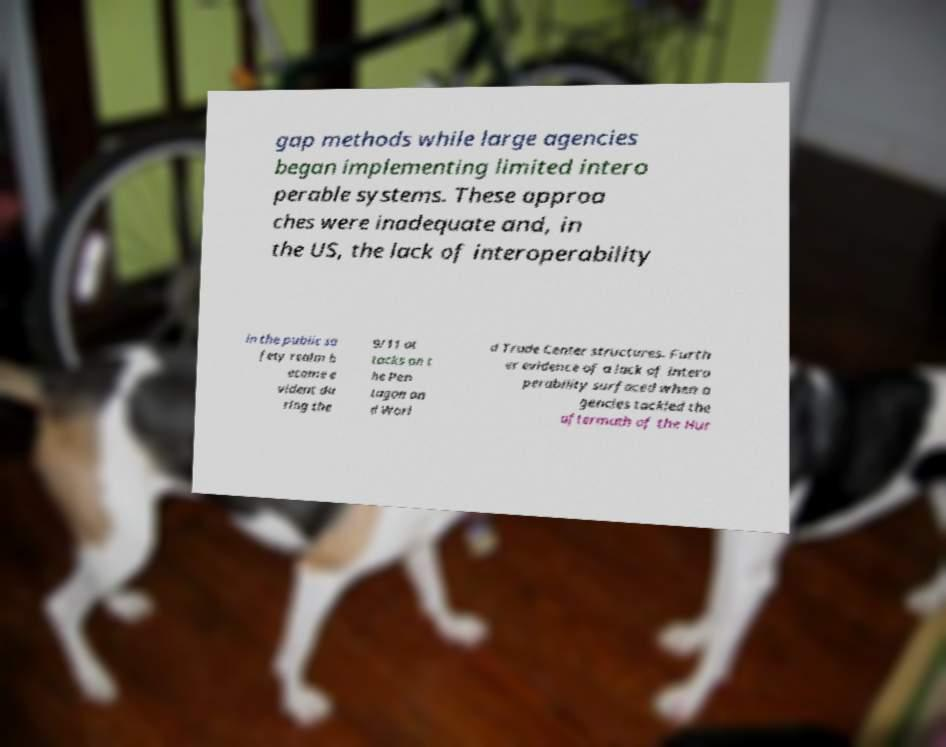Can you accurately transcribe the text from the provided image for me? gap methods while large agencies began implementing limited intero perable systems. These approa ches were inadequate and, in the US, the lack of interoperability in the public sa fety realm b ecome e vident du ring the 9/11 at tacks on t he Pen tagon an d Worl d Trade Center structures. Furth er evidence of a lack of intero perability surfaced when a gencies tackled the aftermath of the Hur 